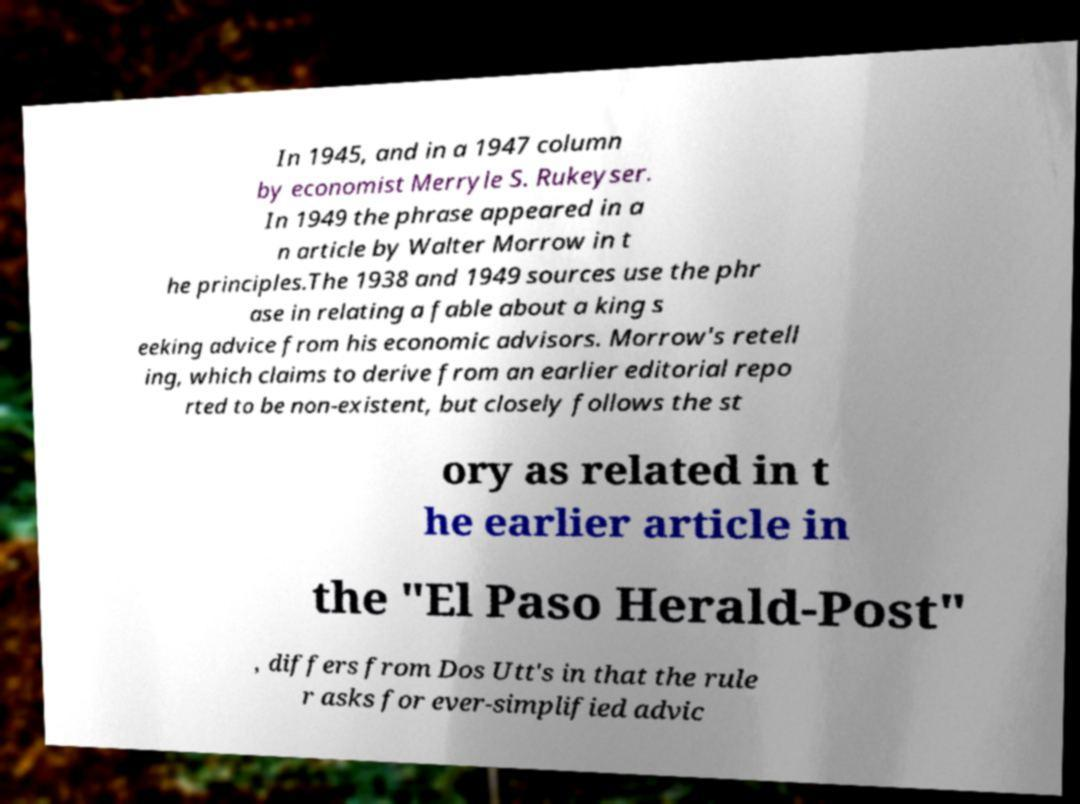Please read and relay the text visible in this image. What does it say? In 1945, and in a 1947 column by economist Merryle S. Rukeyser. In 1949 the phrase appeared in a n article by Walter Morrow in t he principles.The 1938 and 1949 sources use the phr ase in relating a fable about a king s eeking advice from his economic advisors. Morrow's retell ing, which claims to derive from an earlier editorial repo rted to be non-existent, but closely follows the st ory as related in t he earlier article in the "El Paso Herald-Post" , differs from Dos Utt's in that the rule r asks for ever-simplified advic 